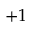Convert formula to latex. <formula><loc_0><loc_0><loc_500><loc_500>+ 1</formula> 